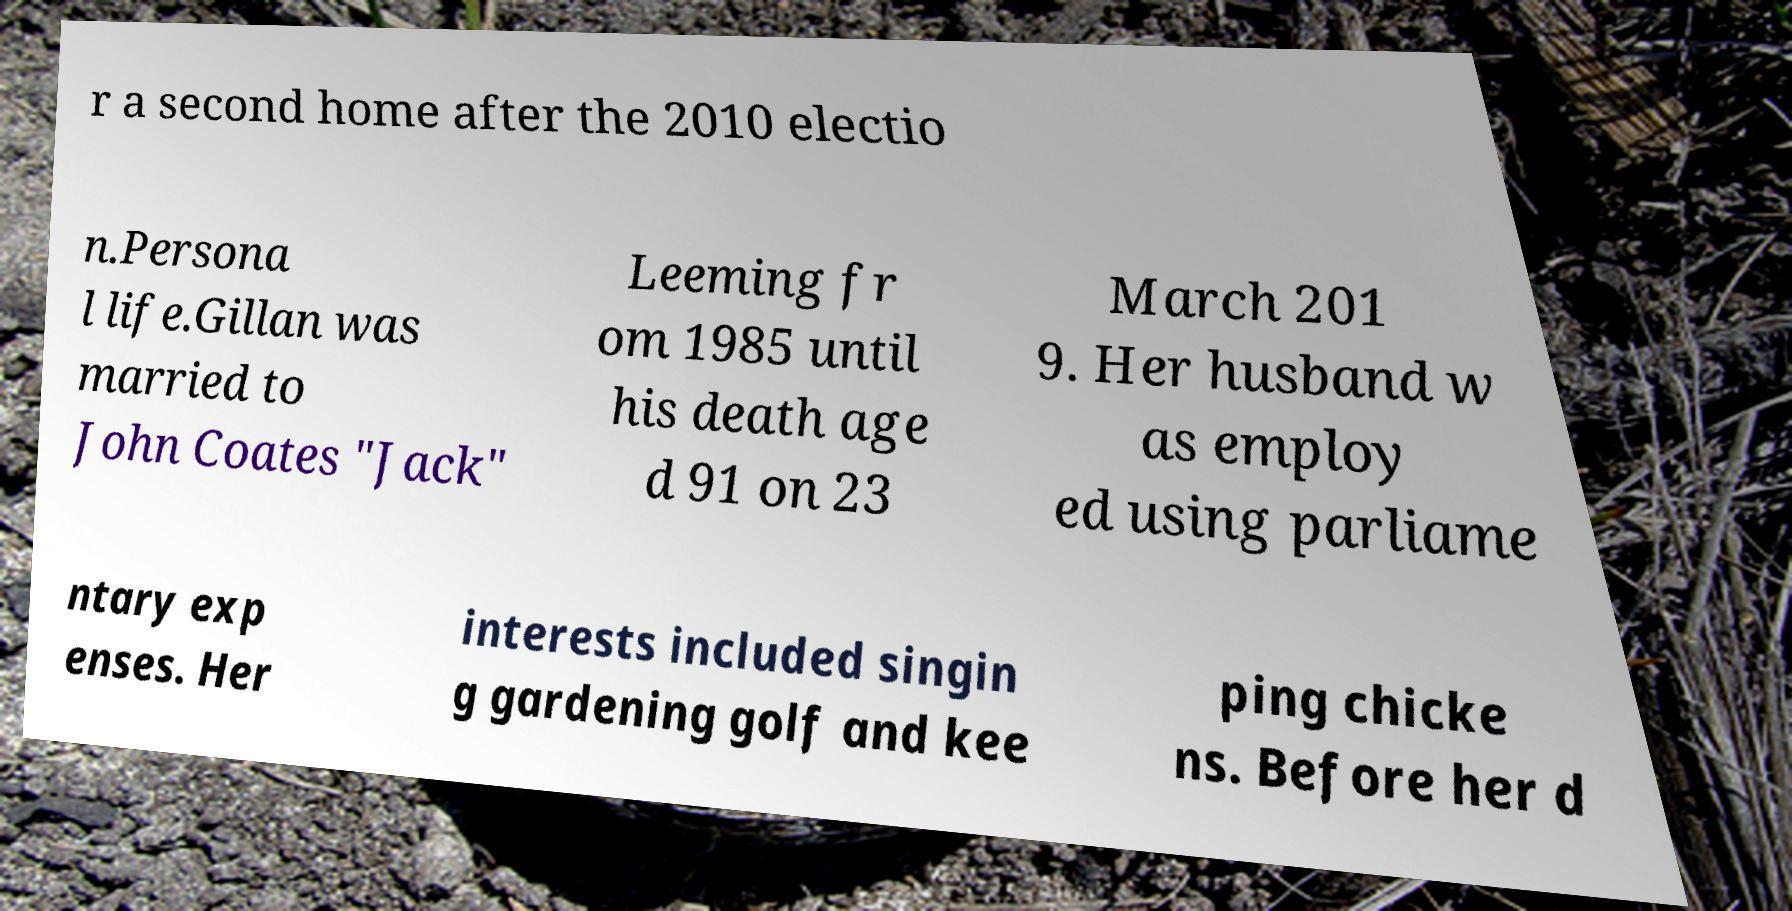Please read and relay the text visible in this image. What does it say? r a second home after the 2010 electio n.Persona l life.Gillan was married to John Coates "Jack" Leeming fr om 1985 until his death age d 91 on 23 March 201 9. Her husband w as employ ed using parliame ntary exp enses. Her interests included singin g gardening golf and kee ping chicke ns. Before her d 